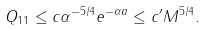Convert formula to latex. <formula><loc_0><loc_0><loc_500><loc_500>\| Q _ { 1 } \| _ { 1 } \leq c \alpha ^ { - 5 / 4 } e ^ { - \alpha a } \leq c ^ { \prime } M ^ { 5 / 4 } .</formula> 